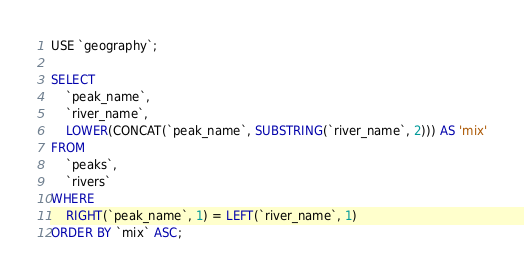<code> <loc_0><loc_0><loc_500><loc_500><_SQL_>USE `geography`;

SELECT 
    `peak_name`,
    `river_name`,
    LOWER(CONCAT(`peak_name`, SUBSTRING(`river_name`, 2))) AS 'mix'
FROM
    `peaks`,
    `rivers`
WHERE
    RIGHT(`peak_name`, 1) = LEFT(`river_name`, 1)
ORDER BY `mix` ASC;</code> 